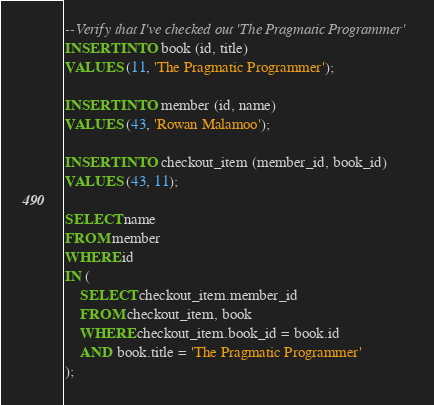Convert code to text. <code><loc_0><loc_0><loc_500><loc_500><_SQL_>--Verify that I've checked out 'The Pragmatic Programmer'
INSERT INTO book (id, title)
VALUES (11, 'The Pragmatic Programmer');

INSERT INTO member (id, name)
VALUES (43, 'Rowan Malamoo');

INSERT INTO checkout_item (member_id, book_id)
VALUES (43, 11);

SELECT name
FROM member
WHERE id
IN (
    SELECT checkout_item.member_id
    FROM checkout_item, book
    WHERE checkout_item.book_id = book.id
    AND book.title = 'The Pragmatic Programmer'
);
</code> 